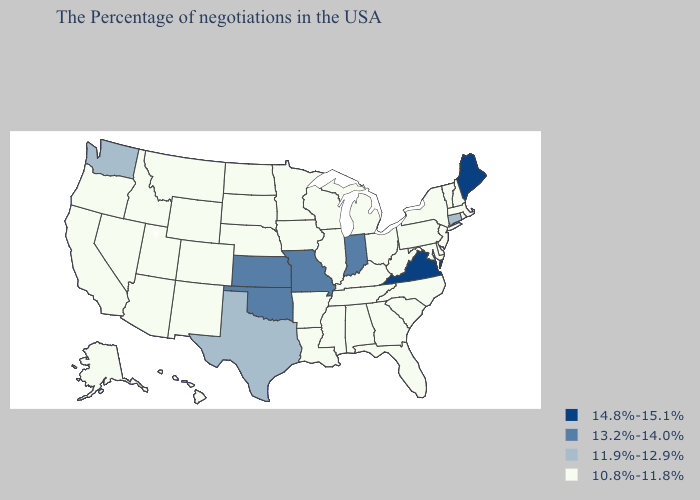Name the states that have a value in the range 11.9%-12.9%?
Quick response, please. Connecticut, Texas, Washington. Does West Virginia have the lowest value in the South?
Be succinct. Yes. What is the value of Connecticut?
Keep it brief. 11.9%-12.9%. Among the states that border Iowa , does Missouri have the highest value?
Be succinct. Yes. Does the map have missing data?
Keep it brief. No. What is the value of Arizona?
Write a very short answer. 10.8%-11.8%. Which states have the highest value in the USA?
Answer briefly. Maine, Virginia. How many symbols are there in the legend?
Be succinct. 4. Name the states that have a value in the range 13.2%-14.0%?
Write a very short answer. Indiana, Missouri, Kansas, Oklahoma. Does Iowa have the lowest value in the USA?
Give a very brief answer. Yes. What is the value of Alaska?
Quick response, please. 10.8%-11.8%. What is the lowest value in the West?
Quick response, please. 10.8%-11.8%. Which states have the highest value in the USA?
Write a very short answer. Maine, Virginia. Which states have the lowest value in the USA?
Concise answer only. Massachusetts, Rhode Island, New Hampshire, Vermont, New York, New Jersey, Delaware, Maryland, Pennsylvania, North Carolina, South Carolina, West Virginia, Ohio, Florida, Georgia, Michigan, Kentucky, Alabama, Tennessee, Wisconsin, Illinois, Mississippi, Louisiana, Arkansas, Minnesota, Iowa, Nebraska, South Dakota, North Dakota, Wyoming, Colorado, New Mexico, Utah, Montana, Arizona, Idaho, Nevada, California, Oregon, Alaska, Hawaii. Does Arizona have a lower value than Illinois?
Be succinct. No. 